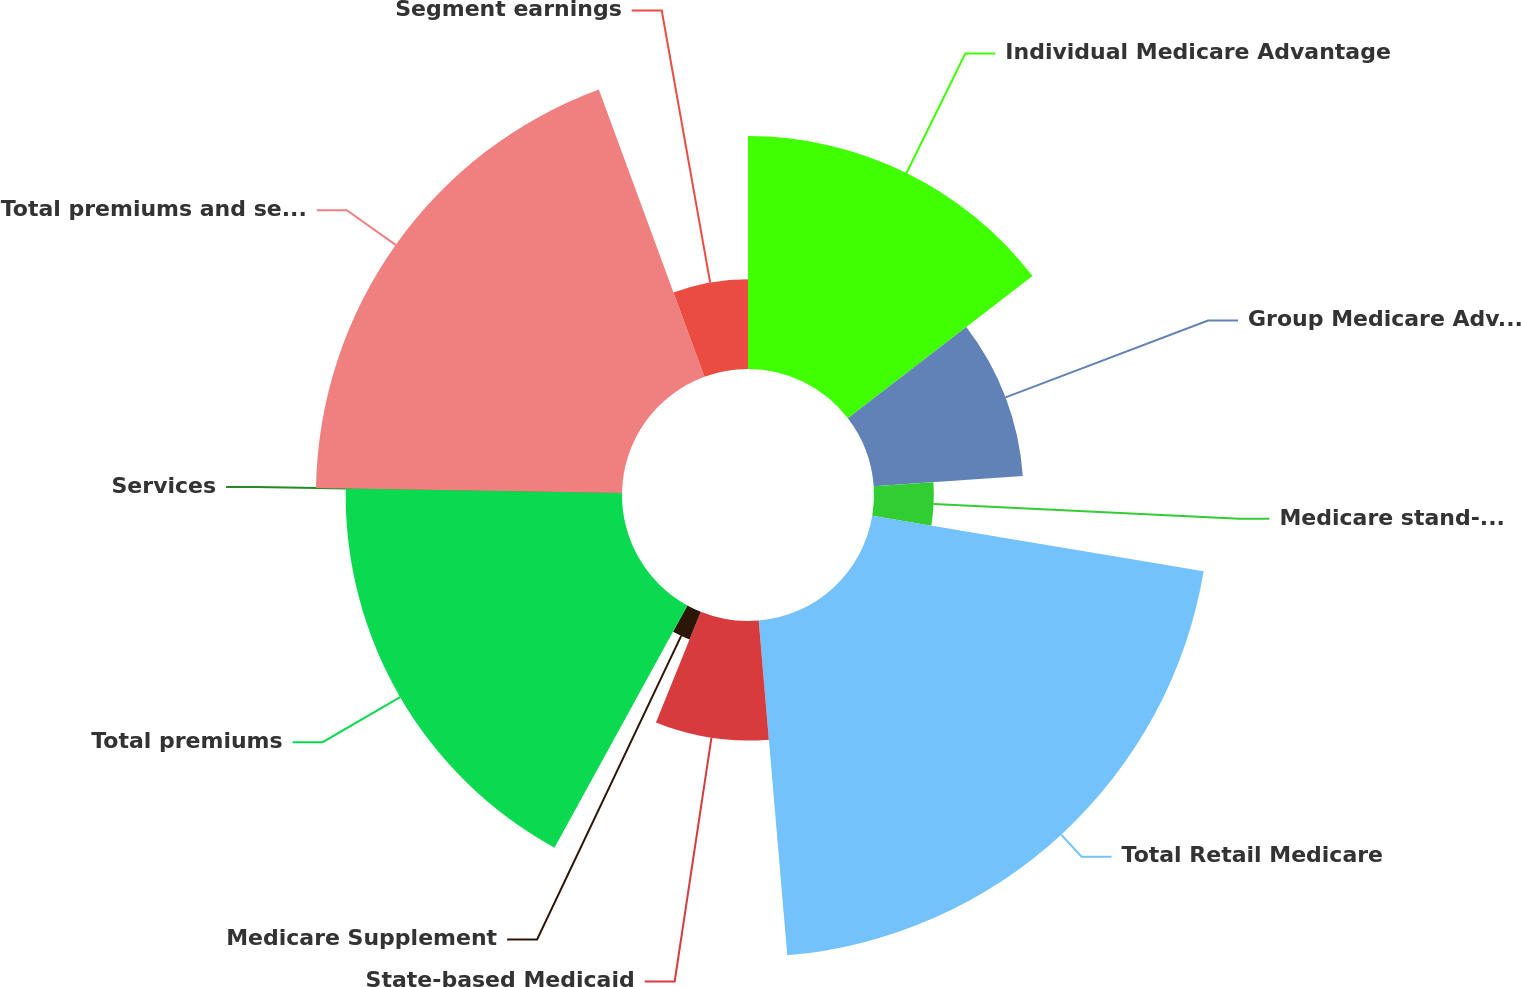<chart> <loc_0><loc_0><loc_500><loc_500><pie_chart><fcel>Individual Medicare Advantage<fcel>Group Medicare Advantage<fcel>Medicare stand-alone PDP<fcel>Total Retail Medicare<fcel>State-based Medicaid<fcel>Medicare Supplement<fcel>Total premiums<fcel>Services<fcel>Total premiums and services<fcel>Segment earnings<nl><fcel>14.56%<fcel>9.34%<fcel>3.74%<fcel>21.0%<fcel>7.47%<fcel>1.87%<fcel>17.27%<fcel>0.0%<fcel>19.13%<fcel>5.61%<nl></chart> 